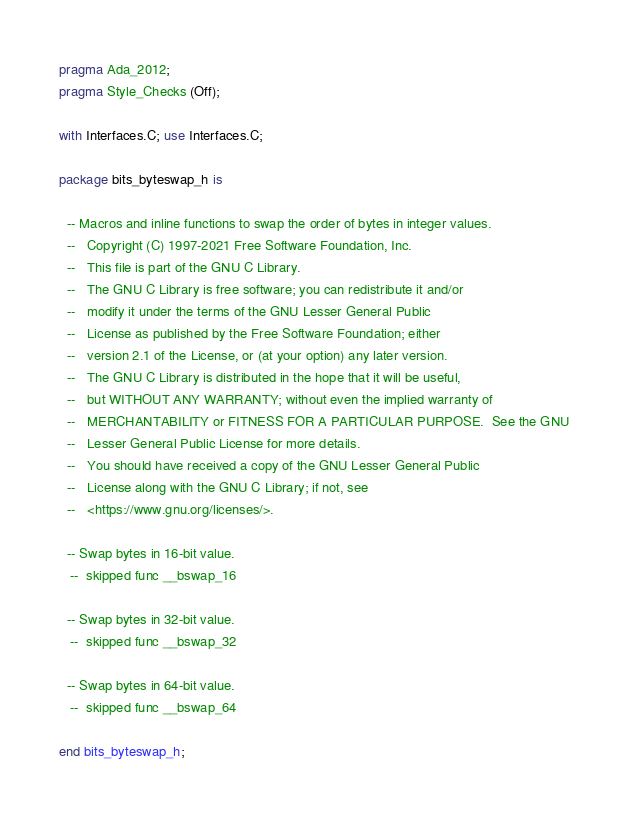Convert code to text. <code><loc_0><loc_0><loc_500><loc_500><_Ada_>pragma Ada_2012;
pragma Style_Checks (Off);

with Interfaces.C; use Interfaces.C;

package bits_byteswap_h is

  -- Macros and inline functions to swap the order of bytes in integer values.
  --   Copyright (C) 1997-2021 Free Software Foundation, Inc.
  --   This file is part of the GNU C Library.
  --   The GNU C Library is free software; you can redistribute it and/or
  --   modify it under the terms of the GNU Lesser General Public
  --   License as published by the Free Software Foundation; either
  --   version 2.1 of the License, or (at your option) any later version.
  --   The GNU C Library is distributed in the hope that it will be useful,
  --   but WITHOUT ANY WARRANTY; without even the implied warranty of
  --   MERCHANTABILITY or FITNESS FOR A PARTICULAR PURPOSE.  See the GNU
  --   Lesser General Public License for more details.
  --   You should have received a copy of the GNU Lesser General Public
  --   License along with the GNU C Library; if not, see
  --   <https://www.gnu.org/licenses/>.   

  -- Swap bytes in 16-bit value.   
   --  skipped func __bswap_16

  -- Swap bytes in 32-bit value.   
   --  skipped func __bswap_32

  -- Swap bytes in 64-bit value.   
   --  skipped func __bswap_64

end bits_byteswap_h;
</code> 